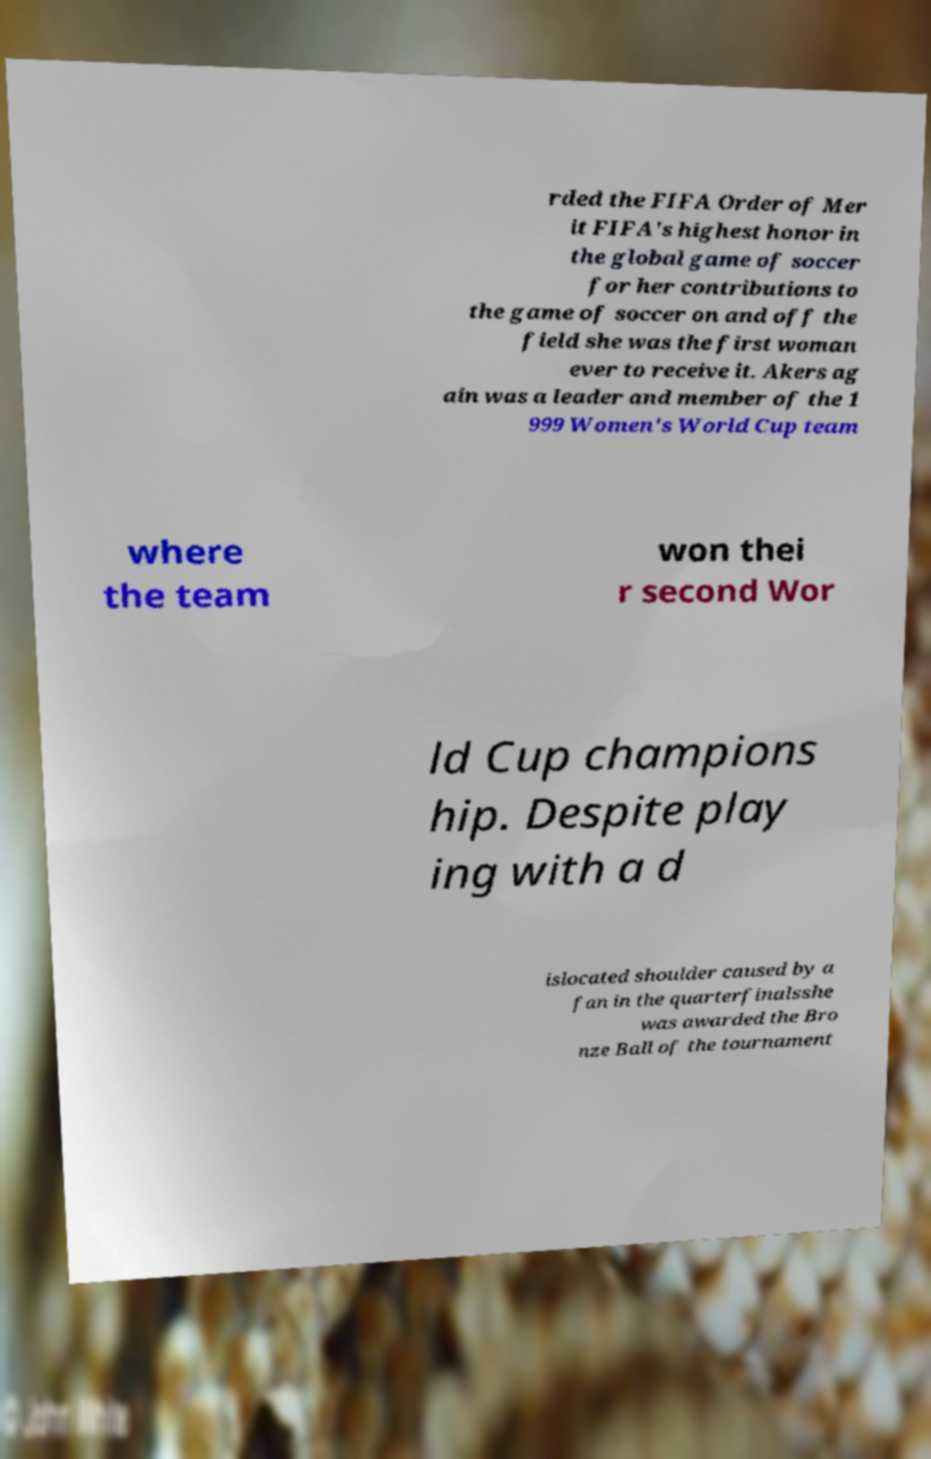I need the written content from this picture converted into text. Can you do that? rded the FIFA Order of Mer it FIFA's highest honor in the global game of soccer for her contributions to the game of soccer on and off the field she was the first woman ever to receive it. Akers ag ain was a leader and member of the 1 999 Women's World Cup team where the team won thei r second Wor ld Cup champions hip. Despite play ing with a d islocated shoulder caused by a fan in the quarterfinalsshe was awarded the Bro nze Ball of the tournament 